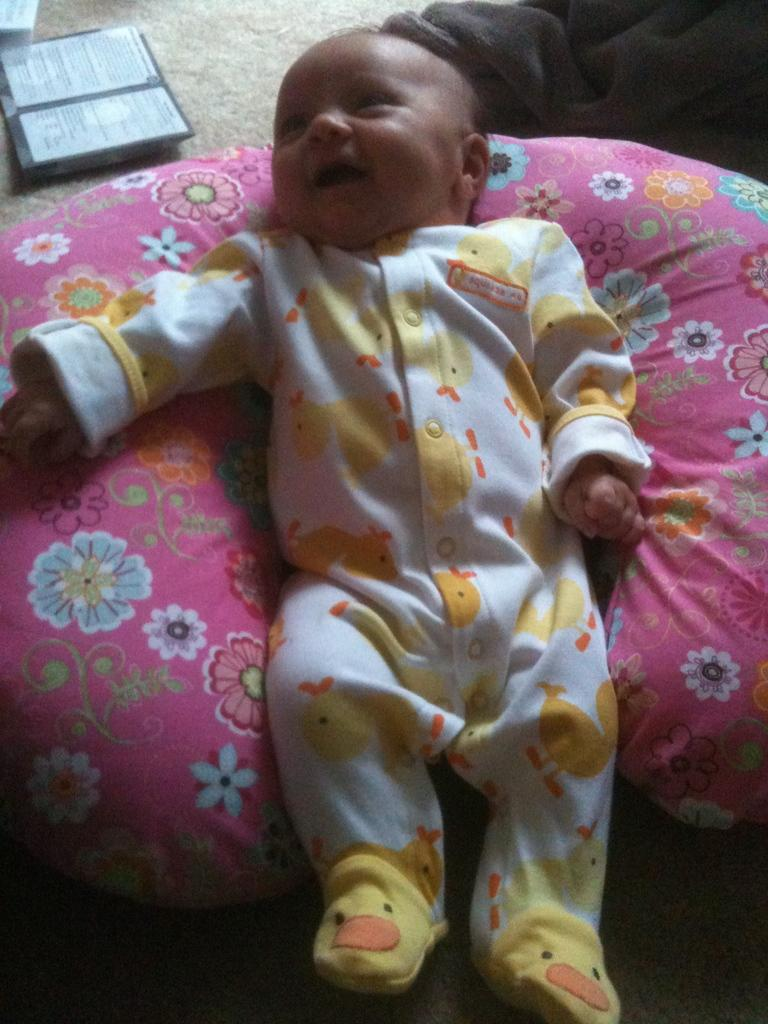What color is the object that the boy is on in the image? The object is pink. What is the boy wearing in the image? The boy is wearing a white and yellow dress. Can you describe any other elements visible in the background of the image? Unfortunately, the provided facts do not give any information about the background elements. What type of relation does the boy have with the pink object in the image? There is no information provided about the boy's relation to the pink object. Can you locate the nearest city on a map based on the image? There is no map or location information provided in the image. 